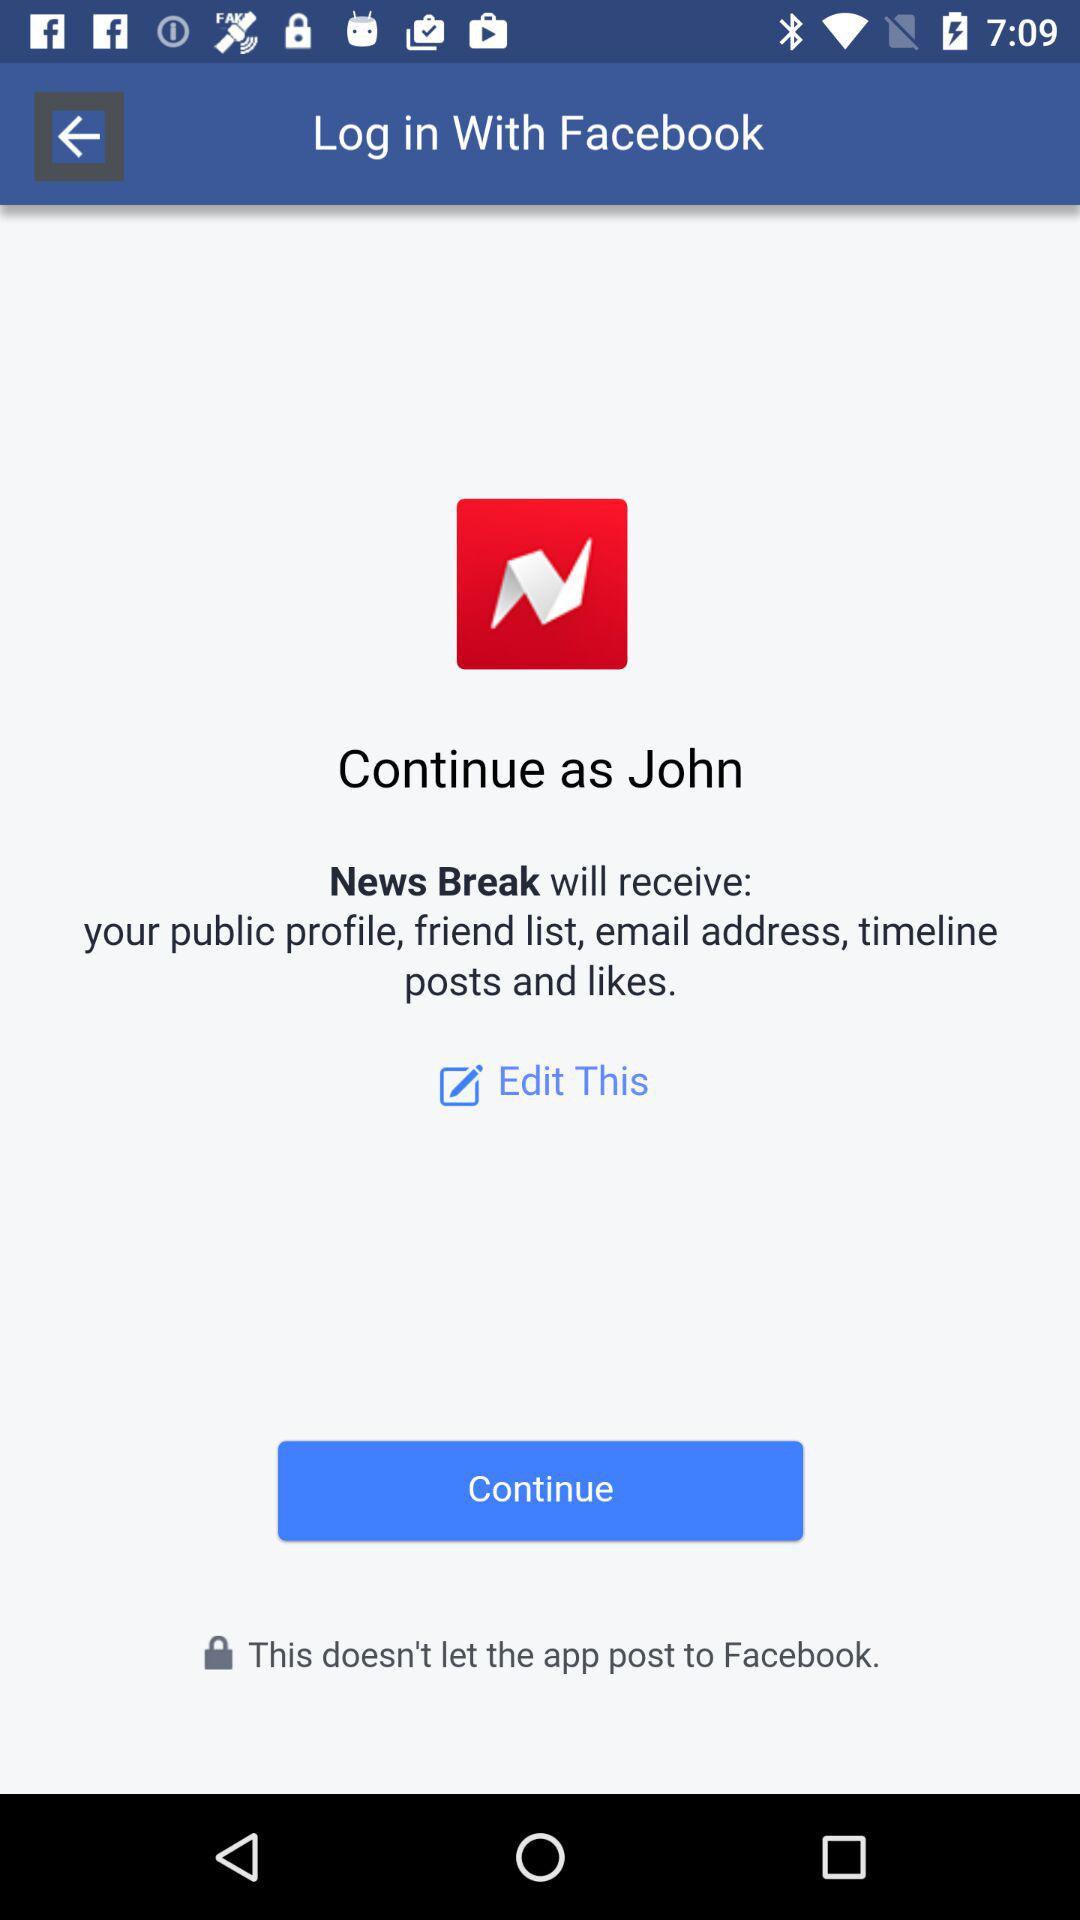What is the name of the user? The name of the user is John. 